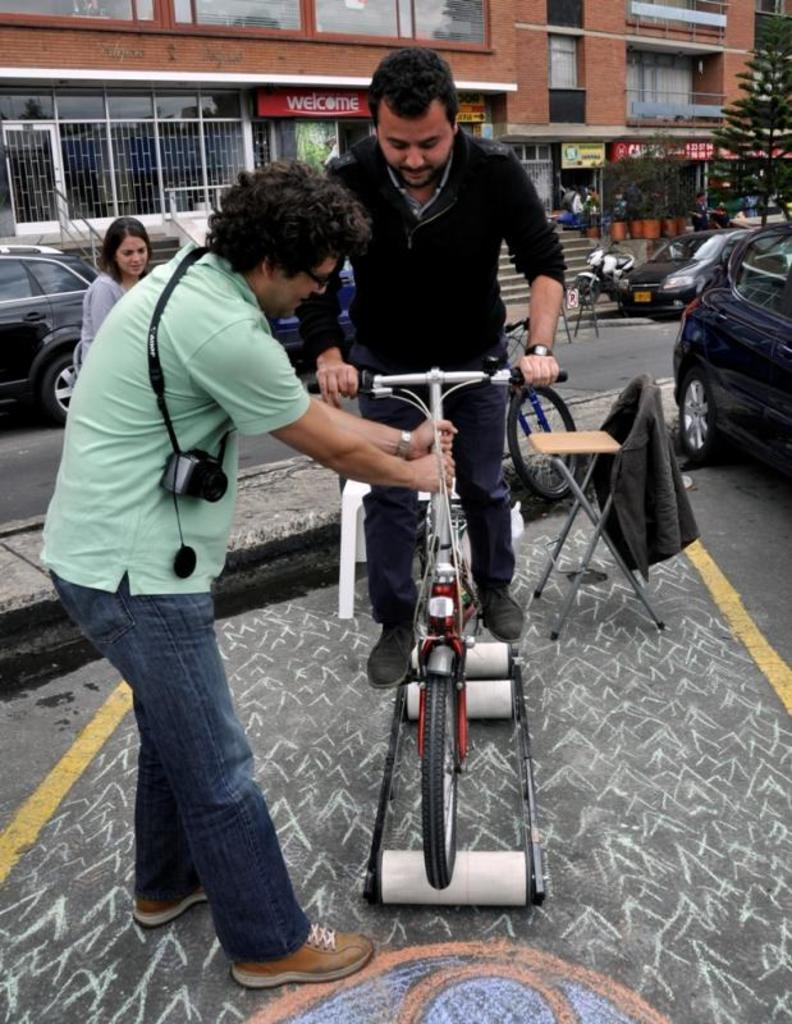How many children are present in the image? There are two boys and a girl in the image, making a total of three children. What is one of the boys doing in the image? One of the boys is sitting on a bicycle. What else can be seen in the image besides the children? There are vehicles and a building visible in the image. What type of vegetable is being used as a toy by the girl in the image? There is no vegetable present in the image, and the girl is not using any object as a toy. 